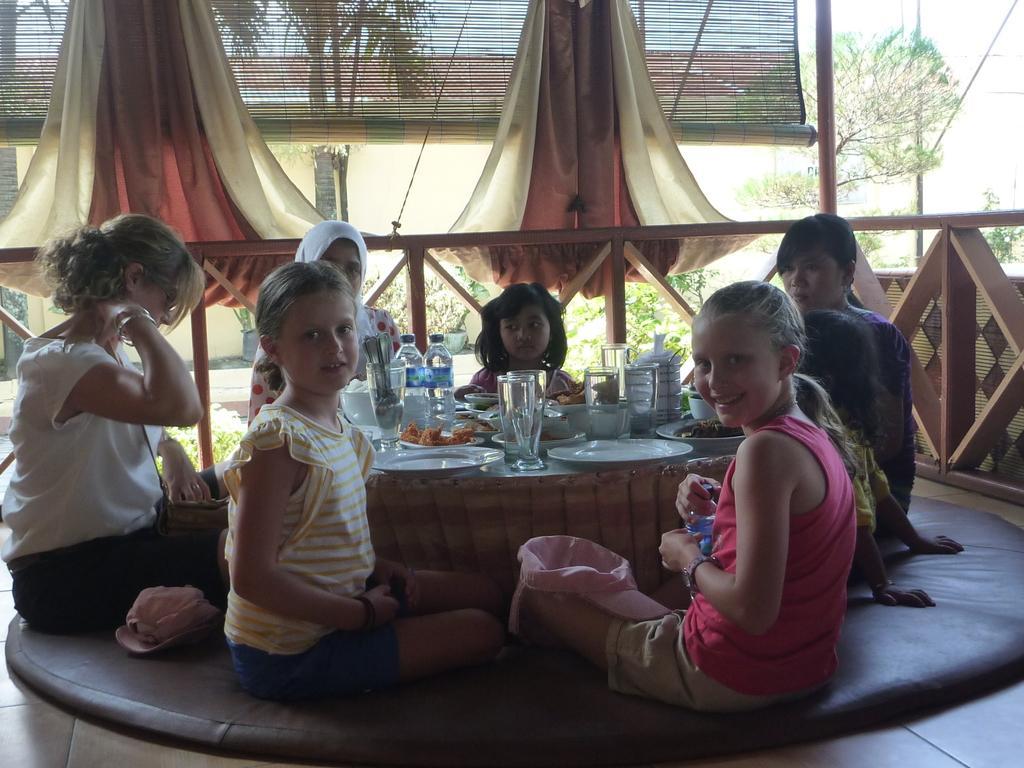How would you summarize this image in a sentence or two? In this picture we can see some persons sitting around the table. These are the plates, glasses, bowls, and bottles on the table. On the background we can see some trees. And this is curtain. This is sky. 